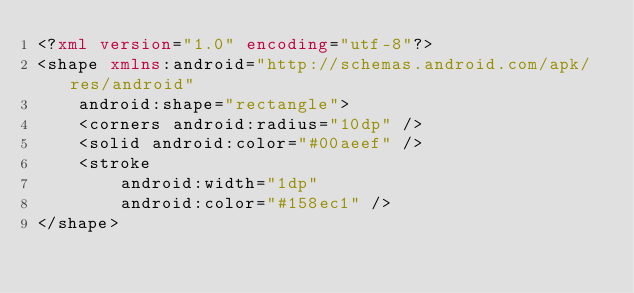Convert code to text. <code><loc_0><loc_0><loc_500><loc_500><_XML_><?xml version="1.0" encoding="utf-8"?>
<shape xmlns:android="http://schemas.android.com/apk/res/android"
    android:shape="rectangle">
    <corners android:radius="10dp" />
    <solid android:color="#00aeef" />
    <stroke
        android:width="1dp"
        android:color="#158ec1" />
</shape></code> 